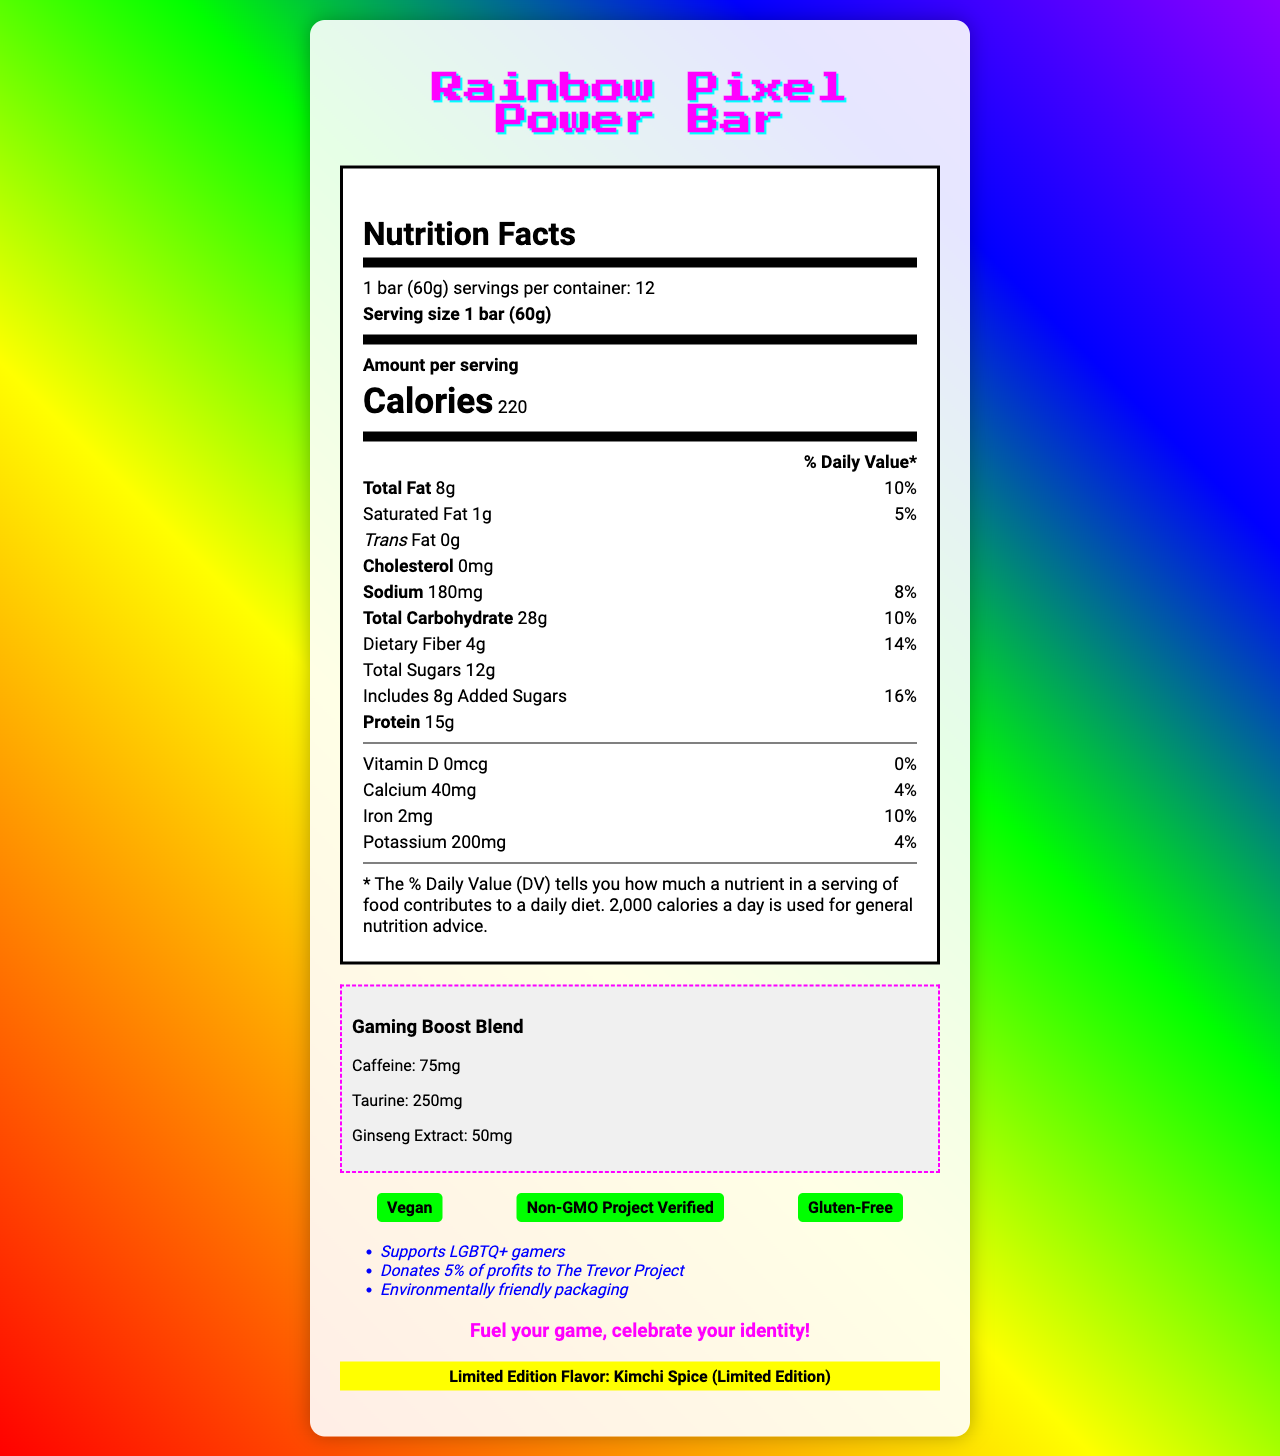how many servings per container are there? The document states that there are 12 servings per container.
Answer: 12 what is the serving size for the Rainbow Pixel Power Bar? The serving size is listed as 1 bar (60g) on the document.
Answer: 1 bar (60g) how many calories are in one serving? The document indicates that each serving contains 220 calories.
Answer: 220 what is the total amount of fat in one serving? The total fat content per serving is 8g as shown in the document.
Answer: 8g how much protein does each bar contain? Each bar contains 15g of protein according to the information provided.
Answer: 15g which ingredient provides the main protein source? A. Almond butter B. Pea protein isolate C. Quinoa crisps Pea protein isolate is listed as the first ingredient, indicating it is the main protein source.
Answer: B how much caffeine is in the gaming boost blend? Under the Gaming Boost Blend section, the document lists caffeine as 75mg.
Answer: 75mg what percentage of daily value of dietary fiber does one bar provide? The document states that one bar provides 14% of the daily value of dietary fiber.
Answer: 14% does the Rainbow Pixel Power Bar contain any cholesterol? The document lists the cholesterol content as 0mg, meaning it contains no cholesterol.
Answer: No what is unique about the flavor of this protein bar? A. Rainbow Sherbet B. Kimchi Spice C. Matcha Green Tea The limited edition flavor inspired by South Korean drama is Kimchi Spice, as indicated in the document.
Answer: B does this product support any LGBTQ+ causes? The document mentions that the product supports LGBTQ+ gamers and donates 5% of profits to The Trevor Project.
Answer: Yes describe the main idea of the document The document details the product's nutritional facts, ingredients, certifications, marketing claims, and unique selling points targeted towards LGBTQ+ gamers, including special contributions to The Trevor Project and a South Korean drama-inspired flavor.
Answer: The Rainbow Pixel Power Bar is a plant-based protein bar designed for LGBTQ+ gamers. It features rainbow packaging, supports LGBTQ+ causes, and offers both nutritional benefits and a gaming boost. It also includes a limited edition Kimchi Spice flavor. what is the potassium content per serving? The document states that each serving contains 200mg of potassium.
Answer: 200mg is the Rainbow Pixel Power Bar gluten-free? The document includes a certification stating the product is gluten-free.
Answer: Yes how long does the average energy boost last after consuming one bar? The document mentions that the average energy boost duration is 3-4 hours.
Answer: 3-4 hours which company manufactures the Rainbow Pixel Power Bar? The document does not provide information regarding the manufacturer of the Rainbow Pixel Power Bar.
Answer: Not enough information 